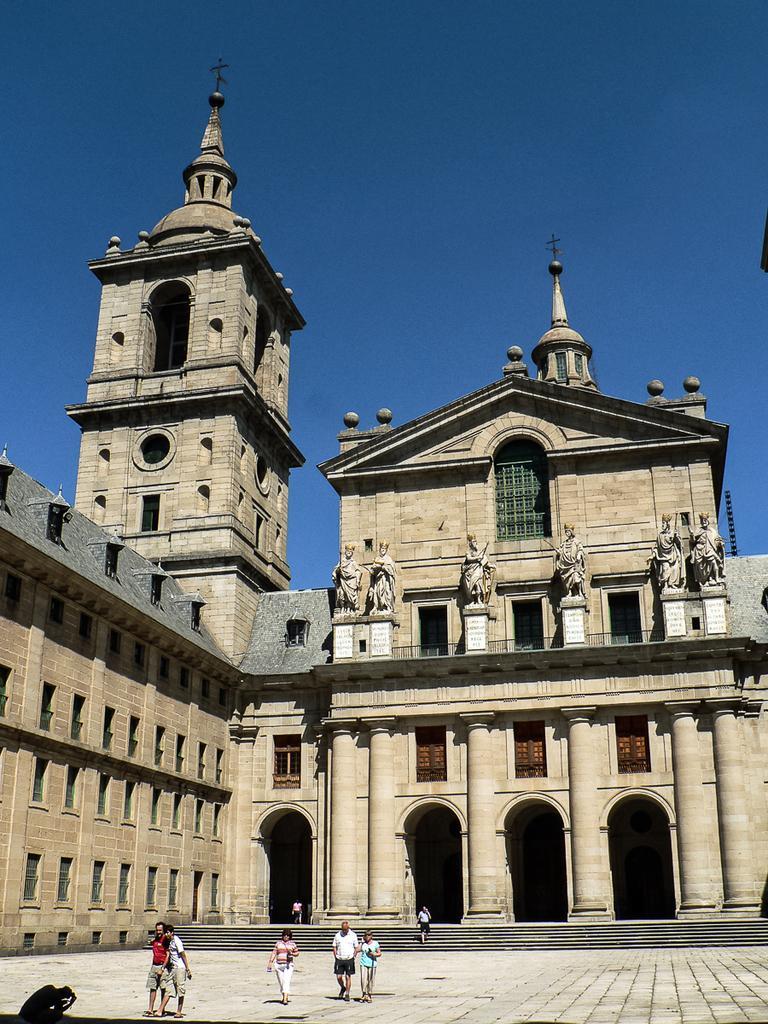How would you summarize this image in a sentence or two? In this image, we can see a building. There are a few people and statues. We can see the ground and some stairs. We can also see the sky. 